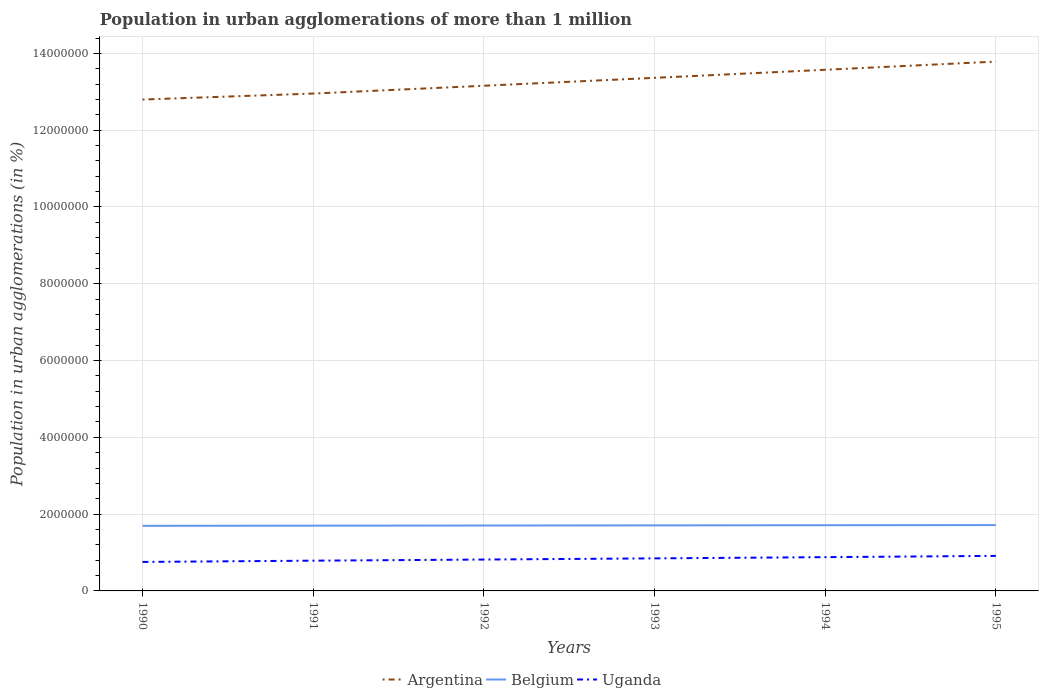Does the line corresponding to Argentina intersect with the line corresponding to Belgium?
Offer a very short reply. No. Is the number of lines equal to the number of legend labels?
Make the answer very short. Yes. Across all years, what is the maximum population in urban agglomerations in Argentina?
Provide a succinct answer. 1.28e+07. In which year was the population in urban agglomerations in Argentina maximum?
Provide a succinct answer. 1990. What is the total population in urban agglomerations in Belgium in the graph?
Offer a terse response. -1.17e+04. What is the difference between the highest and the second highest population in urban agglomerations in Uganda?
Provide a succinct answer. 1.58e+05. What is the difference between the highest and the lowest population in urban agglomerations in Belgium?
Make the answer very short. 3. Is the population in urban agglomerations in Belgium strictly greater than the population in urban agglomerations in Uganda over the years?
Make the answer very short. No. How many lines are there?
Give a very brief answer. 3. Where does the legend appear in the graph?
Your answer should be very brief. Bottom center. How are the legend labels stacked?
Offer a very short reply. Horizontal. What is the title of the graph?
Your answer should be compact. Population in urban agglomerations of more than 1 million. What is the label or title of the X-axis?
Give a very brief answer. Years. What is the label or title of the Y-axis?
Offer a very short reply. Population in urban agglomerations (in %). What is the Population in urban agglomerations (in %) in Argentina in 1990?
Offer a terse response. 1.28e+07. What is the Population in urban agglomerations (in %) in Belgium in 1990?
Your answer should be compact. 1.70e+06. What is the Population in urban agglomerations (in %) of Uganda in 1990?
Offer a terse response. 7.55e+05. What is the Population in urban agglomerations (in %) in Argentina in 1991?
Provide a short and direct response. 1.30e+07. What is the Population in urban agglomerations (in %) in Belgium in 1991?
Ensure brevity in your answer.  1.70e+06. What is the Population in urban agglomerations (in %) of Uganda in 1991?
Your answer should be compact. 7.88e+05. What is the Population in urban agglomerations (in %) in Argentina in 1992?
Offer a very short reply. 1.32e+07. What is the Population in urban agglomerations (in %) of Belgium in 1992?
Ensure brevity in your answer.  1.70e+06. What is the Population in urban agglomerations (in %) in Uganda in 1992?
Provide a short and direct response. 8.17e+05. What is the Population in urban agglomerations (in %) of Argentina in 1993?
Ensure brevity in your answer.  1.34e+07. What is the Population in urban agglomerations (in %) in Belgium in 1993?
Ensure brevity in your answer.  1.71e+06. What is the Population in urban agglomerations (in %) in Uganda in 1993?
Keep it short and to the point. 8.48e+05. What is the Population in urban agglomerations (in %) in Argentina in 1994?
Your answer should be compact. 1.36e+07. What is the Population in urban agglomerations (in %) in Belgium in 1994?
Ensure brevity in your answer.  1.71e+06. What is the Population in urban agglomerations (in %) in Uganda in 1994?
Make the answer very short. 8.80e+05. What is the Population in urban agglomerations (in %) in Argentina in 1995?
Your answer should be compact. 1.38e+07. What is the Population in urban agglomerations (in %) of Belgium in 1995?
Offer a very short reply. 1.71e+06. What is the Population in urban agglomerations (in %) of Uganda in 1995?
Offer a very short reply. 9.12e+05. Across all years, what is the maximum Population in urban agglomerations (in %) of Argentina?
Your answer should be very brief. 1.38e+07. Across all years, what is the maximum Population in urban agglomerations (in %) of Belgium?
Your answer should be compact. 1.71e+06. Across all years, what is the maximum Population in urban agglomerations (in %) of Uganda?
Keep it short and to the point. 9.12e+05. Across all years, what is the minimum Population in urban agglomerations (in %) of Argentina?
Give a very brief answer. 1.28e+07. Across all years, what is the minimum Population in urban agglomerations (in %) of Belgium?
Provide a succinct answer. 1.70e+06. Across all years, what is the minimum Population in urban agglomerations (in %) of Uganda?
Give a very brief answer. 7.55e+05. What is the total Population in urban agglomerations (in %) in Argentina in the graph?
Offer a very short reply. 7.96e+07. What is the total Population in urban agglomerations (in %) of Belgium in the graph?
Give a very brief answer. 1.02e+07. What is the total Population in urban agglomerations (in %) of Uganda in the graph?
Your answer should be compact. 5.00e+06. What is the difference between the Population in urban agglomerations (in %) of Argentina in 1990 and that in 1991?
Provide a short and direct response. -1.56e+05. What is the difference between the Population in urban agglomerations (in %) of Belgium in 1990 and that in 1991?
Offer a terse response. -3884. What is the difference between the Population in urban agglomerations (in %) in Uganda in 1990 and that in 1991?
Give a very brief answer. -3.28e+04. What is the difference between the Population in urban agglomerations (in %) in Argentina in 1990 and that in 1992?
Your response must be concise. -3.59e+05. What is the difference between the Population in urban agglomerations (in %) of Belgium in 1990 and that in 1992?
Offer a terse response. -7781. What is the difference between the Population in urban agglomerations (in %) of Uganda in 1990 and that in 1992?
Keep it short and to the point. -6.24e+04. What is the difference between the Population in urban agglomerations (in %) of Argentina in 1990 and that in 1993?
Provide a short and direct response. -5.65e+05. What is the difference between the Population in urban agglomerations (in %) in Belgium in 1990 and that in 1993?
Provide a short and direct response. -1.17e+04. What is the difference between the Population in urban agglomerations (in %) in Uganda in 1990 and that in 1993?
Offer a very short reply. -9.29e+04. What is the difference between the Population in urban agglomerations (in %) of Argentina in 1990 and that in 1994?
Your response must be concise. -7.75e+05. What is the difference between the Population in urban agglomerations (in %) of Belgium in 1990 and that in 1994?
Your answer should be compact. -1.56e+04. What is the difference between the Population in urban agglomerations (in %) of Uganda in 1990 and that in 1994?
Your answer should be compact. -1.25e+05. What is the difference between the Population in urban agglomerations (in %) in Argentina in 1990 and that in 1995?
Make the answer very short. -9.88e+05. What is the difference between the Population in urban agglomerations (in %) in Belgium in 1990 and that in 1995?
Ensure brevity in your answer.  -1.95e+04. What is the difference between the Population in urban agglomerations (in %) of Uganda in 1990 and that in 1995?
Give a very brief answer. -1.58e+05. What is the difference between the Population in urban agglomerations (in %) of Argentina in 1991 and that in 1992?
Your answer should be very brief. -2.03e+05. What is the difference between the Population in urban agglomerations (in %) of Belgium in 1991 and that in 1992?
Offer a terse response. -3897. What is the difference between the Population in urban agglomerations (in %) of Uganda in 1991 and that in 1992?
Your answer should be compact. -2.95e+04. What is the difference between the Population in urban agglomerations (in %) in Argentina in 1991 and that in 1993?
Your answer should be compact. -4.10e+05. What is the difference between the Population in urban agglomerations (in %) of Belgium in 1991 and that in 1993?
Keep it short and to the point. -7793. What is the difference between the Population in urban agglomerations (in %) of Uganda in 1991 and that in 1993?
Your response must be concise. -6.01e+04. What is the difference between the Population in urban agglomerations (in %) in Argentina in 1991 and that in 1994?
Provide a succinct answer. -6.19e+05. What is the difference between the Population in urban agglomerations (in %) in Belgium in 1991 and that in 1994?
Offer a very short reply. -1.17e+04. What is the difference between the Population in urban agglomerations (in %) of Uganda in 1991 and that in 1994?
Give a very brief answer. -9.19e+04. What is the difference between the Population in urban agglomerations (in %) of Argentina in 1991 and that in 1995?
Give a very brief answer. -8.33e+05. What is the difference between the Population in urban agglomerations (in %) in Belgium in 1991 and that in 1995?
Keep it short and to the point. -1.56e+04. What is the difference between the Population in urban agglomerations (in %) of Uganda in 1991 and that in 1995?
Your answer should be compact. -1.25e+05. What is the difference between the Population in urban agglomerations (in %) in Argentina in 1992 and that in 1993?
Keep it short and to the point. -2.06e+05. What is the difference between the Population in urban agglomerations (in %) of Belgium in 1992 and that in 1993?
Provide a succinct answer. -3896. What is the difference between the Population in urban agglomerations (in %) of Uganda in 1992 and that in 1993?
Ensure brevity in your answer.  -3.06e+04. What is the difference between the Population in urban agglomerations (in %) of Argentina in 1992 and that in 1994?
Ensure brevity in your answer.  -4.16e+05. What is the difference between the Population in urban agglomerations (in %) of Belgium in 1992 and that in 1994?
Your answer should be compact. -7806. What is the difference between the Population in urban agglomerations (in %) in Uganda in 1992 and that in 1994?
Your response must be concise. -6.23e+04. What is the difference between the Population in urban agglomerations (in %) in Argentina in 1992 and that in 1995?
Ensure brevity in your answer.  -6.29e+05. What is the difference between the Population in urban agglomerations (in %) of Belgium in 1992 and that in 1995?
Your response must be concise. -1.17e+04. What is the difference between the Population in urban agglomerations (in %) of Uganda in 1992 and that in 1995?
Provide a short and direct response. -9.53e+04. What is the difference between the Population in urban agglomerations (in %) of Argentina in 1993 and that in 1994?
Provide a short and direct response. -2.10e+05. What is the difference between the Population in urban agglomerations (in %) in Belgium in 1993 and that in 1994?
Keep it short and to the point. -3910. What is the difference between the Population in urban agglomerations (in %) of Uganda in 1993 and that in 1994?
Ensure brevity in your answer.  -3.18e+04. What is the difference between the Population in urban agglomerations (in %) in Argentina in 1993 and that in 1995?
Ensure brevity in your answer.  -4.23e+05. What is the difference between the Population in urban agglomerations (in %) in Belgium in 1993 and that in 1995?
Your answer should be compact. -7829. What is the difference between the Population in urban agglomerations (in %) of Uganda in 1993 and that in 1995?
Offer a terse response. -6.47e+04. What is the difference between the Population in urban agglomerations (in %) of Argentina in 1994 and that in 1995?
Offer a terse response. -2.13e+05. What is the difference between the Population in urban agglomerations (in %) in Belgium in 1994 and that in 1995?
Your answer should be compact. -3919. What is the difference between the Population in urban agglomerations (in %) in Uganda in 1994 and that in 1995?
Keep it short and to the point. -3.29e+04. What is the difference between the Population in urban agglomerations (in %) of Argentina in 1990 and the Population in urban agglomerations (in %) of Belgium in 1991?
Make the answer very short. 1.11e+07. What is the difference between the Population in urban agglomerations (in %) of Argentina in 1990 and the Population in urban agglomerations (in %) of Uganda in 1991?
Keep it short and to the point. 1.20e+07. What is the difference between the Population in urban agglomerations (in %) in Belgium in 1990 and the Population in urban agglomerations (in %) in Uganda in 1991?
Your answer should be very brief. 9.08e+05. What is the difference between the Population in urban agglomerations (in %) of Argentina in 1990 and the Population in urban agglomerations (in %) of Belgium in 1992?
Give a very brief answer. 1.11e+07. What is the difference between the Population in urban agglomerations (in %) in Argentina in 1990 and the Population in urban agglomerations (in %) in Uganda in 1992?
Provide a short and direct response. 1.20e+07. What is the difference between the Population in urban agglomerations (in %) in Belgium in 1990 and the Population in urban agglomerations (in %) in Uganda in 1992?
Offer a very short reply. 8.78e+05. What is the difference between the Population in urban agglomerations (in %) of Argentina in 1990 and the Population in urban agglomerations (in %) of Belgium in 1993?
Make the answer very short. 1.11e+07. What is the difference between the Population in urban agglomerations (in %) in Argentina in 1990 and the Population in urban agglomerations (in %) in Uganda in 1993?
Your answer should be very brief. 1.19e+07. What is the difference between the Population in urban agglomerations (in %) of Belgium in 1990 and the Population in urban agglomerations (in %) of Uganda in 1993?
Provide a succinct answer. 8.48e+05. What is the difference between the Population in urban agglomerations (in %) in Argentina in 1990 and the Population in urban agglomerations (in %) in Belgium in 1994?
Keep it short and to the point. 1.11e+07. What is the difference between the Population in urban agglomerations (in %) of Argentina in 1990 and the Population in urban agglomerations (in %) of Uganda in 1994?
Your answer should be very brief. 1.19e+07. What is the difference between the Population in urban agglomerations (in %) of Belgium in 1990 and the Population in urban agglomerations (in %) of Uganda in 1994?
Your answer should be very brief. 8.16e+05. What is the difference between the Population in urban agglomerations (in %) in Argentina in 1990 and the Population in urban agglomerations (in %) in Belgium in 1995?
Make the answer very short. 1.11e+07. What is the difference between the Population in urban agglomerations (in %) of Argentina in 1990 and the Population in urban agglomerations (in %) of Uganda in 1995?
Your answer should be compact. 1.19e+07. What is the difference between the Population in urban agglomerations (in %) in Belgium in 1990 and the Population in urban agglomerations (in %) in Uganda in 1995?
Give a very brief answer. 7.83e+05. What is the difference between the Population in urban agglomerations (in %) in Argentina in 1991 and the Population in urban agglomerations (in %) in Belgium in 1992?
Give a very brief answer. 1.12e+07. What is the difference between the Population in urban agglomerations (in %) of Argentina in 1991 and the Population in urban agglomerations (in %) of Uganda in 1992?
Keep it short and to the point. 1.21e+07. What is the difference between the Population in urban agglomerations (in %) of Belgium in 1991 and the Population in urban agglomerations (in %) of Uganda in 1992?
Your response must be concise. 8.82e+05. What is the difference between the Population in urban agglomerations (in %) of Argentina in 1991 and the Population in urban agglomerations (in %) of Belgium in 1993?
Give a very brief answer. 1.12e+07. What is the difference between the Population in urban agglomerations (in %) of Argentina in 1991 and the Population in urban agglomerations (in %) of Uganda in 1993?
Give a very brief answer. 1.21e+07. What is the difference between the Population in urban agglomerations (in %) in Belgium in 1991 and the Population in urban agglomerations (in %) in Uganda in 1993?
Your response must be concise. 8.52e+05. What is the difference between the Population in urban agglomerations (in %) in Argentina in 1991 and the Population in urban agglomerations (in %) in Belgium in 1994?
Ensure brevity in your answer.  1.12e+07. What is the difference between the Population in urban agglomerations (in %) in Argentina in 1991 and the Population in urban agglomerations (in %) in Uganda in 1994?
Keep it short and to the point. 1.21e+07. What is the difference between the Population in urban agglomerations (in %) of Belgium in 1991 and the Population in urban agglomerations (in %) of Uganda in 1994?
Ensure brevity in your answer.  8.20e+05. What is the difference between the Population in urban agglomerations (in %) of Argentina in 1991 and the Population in urban agglomerations (in %) of Belgium in 1995?
Provide a short and direct response. 1.12e+07. What is the difference between the Population in urban agglomerations (in %) of Argentina in 1991 and the Population in urban agglomerations (in %) of Uganda in 1995?
Your answer should be very brief. 1.20e+07. What is the difference between the Population in urban agglomerations (in %) in Belgium in 1991 and the Population in urban agglomerations (in %) in Uganda in 1995?
Keep it short and to the point. 7.87e+05. What is the difference between the Population in urban agglomerations (in %) in Argentina in 1992 and the Population in urban agglomerations (in %) in Belgium in 1993?
Your response must be concise. 1.14e+07. What is the difference between the Population in urban agglomerations (in %) of Argentina in 1992 and the Population in urban agglomerations (in %) of Uganda in 1993?
Offer a terse response. 1.23e+07. What is the difference between the Population in urban agglomerations (in %) of Belgium in 1992 and the Population in urban agglomerations (in %) of Uganda in 1993?
Provide a succinct answer. 8.55e+05. What is the difference between the Population in urban agglomerations (in %) of Argentina in 1992 and the Population in urban agglomerations (in %) of Belgium in 1994?
Give a very brief answer. 1.14e+07. What is the difference between the Population in urban agglomerations (in %) of Argentina in 1992 and the Population in urban agglomerations (in %) of Uganda in 1994?
Your answer should be compact. 1.23e+07. What is the difference between the Population in urban agglomerations (in %) of Belgium in 1992 and the Population in urban agglomerations (in %) of Uganda in 1994?
Give a very brief answer. 8.24e+05. What is the difference between the Population in urban agglomerations (in %) of Argentina in 1992 and the Population in urban agglomerations (in %) of Belgium in 1995?
Your answer should be compact. 1.14e+07. What is the difference between the Population in urban agglomerations (in %) in Argentina in 1992 and the Population in urban agglomerations (in %) in Uganda in 1995?
Offer a terse response. 1.22e+07. What is the difference between the Population in urban agglomerations (in %) of Belgium in 1992 and the Population in urban agglomerations (in %) of Uganda in 1995?
Offer a terse response. 7.91e+05. What is the difference between the Population in urban agglomerations (in %) in Argentina in 1993 and the Population in urban agglomerations (in %) in Belgium in 1994?
Ensure brevity in your answer.  1.17e+07. What is the difference between the Population in urban agglomerations (in %) of Argentina in 1993 and the Population in urban agglomerations (in %) of Uganda in 1994?
Provide a succinct answer. 1.25e+07. What is the difference between the Population in urban agglomerations (in %) in Belgium in 1993 and the Population in urban agglomerations (in %) in Uganda in 1994?
Ensure brevity in your answer.  8.28e+05. What is the difference between the Population in urban agglomerations (in %) in Argentina in 1993 and the Population in urban agglomerations (in %) in Belgium in 1995?
Provide a short and direct response. 1.16e+07. What is the difference between the Population in urban agglomerations (in %) in Argentina in 1993 and the Population in urban agglomerations (in %) in Uganda in 1995?
Keep it short and to the point. 1.25e+07. What is the difference between the Population in urban agglomerations (in %) in Belgium in 1993 and the Population in urban agglomerations (in %) in Uganda in 1995?
Offer a terse response. 7.95e+05. What is the difference between the Population in urban agglomerations (in %) of Argentina in 1994 and the Population in urban agglomerations (in %) of Belgium in 1995?
Offer a terse response. 1.19e+07. What is the difference between the Population in urban agglomerations (in %) of Argentina in 1994 and the Population in urban agglomerations (in %) of Uganda in 1995?
Your answer should be compact. 1.27e+07. What is the difference between the Population in urban agglomerations (in %) in Belgium in 1994 and the Population in urban agglomerations (in %) in Uganda in 1995?
Ensure brevity in your answer.  7.99e+05. What is the average Population in urban agglomerations (in %) of Argentina per year?
Ensure brevity in your answer.  1.33e+07. What is the average Population in urban agglomerations (in %) in Belgium per year?
Provide a succinct answer. 1.71e+06. What is the average Population in urban agglomerations (in %) in Uganda per year?
Keep it short and to the point. 8.33e+05. In the year 1990, what is the difference between the Population in urban agglomerations (in %) in Argentina and Population in urban agglomerations (in %) in Belgium?
Give a very brief answer. 1.11e+07. In the year 1990, what is the difference between the Population in urban agglomerations (in %) of Argentina and Population in urban agglomerations (in %) of Uganda?
Your response must be concise. 1.20e+07. In the year 1990, what is the difference between the Population in urban agglomerations (in %) in Belgium and Population in urban agglomerations (in %) in Uganda?
Give a very brief answer. 9.41e+05. In the year 1991, what is the difference between the Population in urban agglomerations (in %) in Argentina and Population in urban agglomerations (in %) in Belgium?
Provide a succinct answer. 1.13e+07. In the year 1991, what is the difference between the Population in urban agglomerations (in %) in Argentina and Population in urban agglomerations (in %) in Uganda?
Offer a very short reply. 1.22e+07. In the year 1991, what is the difference between the Population in urban agglomerations (in %) of Belgium and Population in urban agglomerations (in %) of Uganda?
Ensure brevity in your answer.  9.12e+05. In the year 1992, what is the difference between the Population in urban agglomerations (in %) of Argentina and Population in urban agglomerations (in %) of Belgium?
Offer a very short reply. 1.15e+07. In the year 1992, what is the difference between the Population in urban agglomerations (in %) of Argentina and Population in urban agglomerations (in %) of Uganda?
Keep it short and to the point. 1.23e+07. In the year 1992, what is the difference between the Population in urban agglomerations (in %) of Belgium and Population in urban agglomerations (in %) of Uganda?
Your answer should be compact. 8.86e+05. In the year 1993, what is the difference between the Population in urban agglomerations (in %) of Argentina and Population in urban agglomerations (in %) of Belgium?
Provide a succinct answer. 1.17e+07. In the year 1993, what is the difference between the Population in urban agglomerations (in %) in Argentina and Population in urban agglomerations (in %) in Uganda?
Offer a very short reply. 1.25e+07. In the year 1993, what is the difference between the Population in urban agglomerations (in %) of Belgium and Population in urban agglomerations (in %) of Uganda?
Your answer should be compact. 8.59e+05. In the year 1994, what is the difference between the Population in urban agglomerations (in %) in Argentina and Population in urban agglomerations (in %) in Belgium?
Provide a short and direct response. 1.19e+07. In the year 1994, what is the difference between the Population in urban agglomerations (in %) of Argentina and Population in urban agglomerations (in %) of Uganda?
Give a very brief answer. 1.27e+07. In the year 1994, what is the difference between the Population in urban agglomerations (in %) of Belgium and Population in urban agglomerations (in %) of Uganda?
Make the answer very short. 8.32e+05. In the year 1995, what is the difference between the Population in urban agglomerations (in %) of Argentina and Population in urban agglomerations (in %) of Belgium?
Ensure brevity in your answer.  1.21e+07. In the year 1995, what is the difference between the Population in urban agglomerations (in %) of Argentina and Population in urban agglomerations (in %) of Uganda?
Give a very brief answer. 1.29e+07. In the year 1995, what is the difference between the Population in urban agglomerations (in %) in Belgium and Population in urban agglomerations (in %) in Uganda?
Offer a very short reply. 8.02e+05. What is the ratio of the Population in urban agglomerations (in %) of Argentina in 1990 to that in 1991?
Ensure brevity in your answer.  0.99. What is the ratio of the Population in urban agglomerations (in %) in Belgium in 1990 to that in 1991?
Offer a very short reply. 1. What is the ratio of the Population in urban agglomerations (in %) of Uganda in 1990 to that in 1991?
Provide a succinct answer. 0.96. What is the ratio of the Population in urban agglomerations (in %) of Argentina in 1990 to that in 1992?
Your response must be concise. 0.97. What is the ratio of the Population in urban agglomerations (in %) in Belgium in 1990 to that in 1992?
Provide a short and direct response. 1. What is the ratio of the Population in urban agglomerations (in %) of Uganda in 1990 to that in 1992?
Offer a very short reply. 0.92. What is the ratio of the Population in urban agglomerations (in %) of Argentina in 1990 to that in 1993?
Make the answer very short. 0.96. What is the ratio of the Population in urban agglomerations (in %) of Uganda in 1990 to that in 1993?
Your answer should be compact. 0.89. What is the ratio of the Population in urban agglomerations (in %) in Argentina in 1990 to that in 1994?
Make the answer very short. 0.94. What is the ratio of the Population in urban agglomerations (in %) of Belgium in 1990 to that in 1994?
Ensure brevity in your answer.  0.99. What is the ratio of the Population in urban agglomerations (in %) in Uganda in 1990 to that in 1994?
Provide a short and direct response. 0.86. What is the ratio of the Population in urban agglomerations (in %) of Argentina in 1990 to that in 1995?
Provide a succinct answer. 0.93. What is the ratio of the Population in urban agglomerations (in %) in Uganda in 1990 to that in 1995?
Offer a terse response. 0.83. What is the ratio of the Population in urban agglomerations (in %) of Argentina in 1991 to that in 1992?
Provide a succinct answer. 0.98. What is the ratio of the Population in urban agglomerations (in %) in Uganda in 1991 to that in 1992?
Your response must be concise. 0.96. What is the ratio of the Population in urban agglomerations (in %) of Argentina in 1991 to that in 1993?
Provide a succinct answer. 0.97. What is the ratio of the Population in urban agglomerations (in %) of Uganda in 1991 to that in 1993?
Offer a very short reply. 0.93. What is the ratio of the Population in urban agglomerations (in %) in Argentina in 1991 to that in 1994?
Offer a terse response. 0.95. What is the ratio of the Population in urban agglomerations (in %) in Uganda in 1991 to that in 1994?
Your response must be concise. 0.9. What is the ratio of the Population in urban agglomerations (in %) in Argentina in 1991 to that in 1995?
Your response must be concise. 0.94. What is the ratio of the Population in urban agglomerations (in %) in Belgium in 1991 to that in 1995?
Offer a terse response. 0.99. What is the ratio of the Population in urban agglomerations (in %) in Uganda in 1991 to that in 1995?
Provide a short and direct response. 0.86. What is the ratio of the Population in urban agglomerations (in %) of Argentina in 1992 to that in 1993?
Your response must be concise. 0.98. What is the ratio of the Population in urban agglomerations (in %) of Uganda in 1992 to that in 1993?
Your answer should be compact. 0.96. What is the ratio of the Population in urban agglomerations (in %) of Argentina in 1992 to that in 1994?
Provide a succinct answer. 0.97. What is the ratio of the Population in urban agglomerations (in %) of Belgium in 1992 to that in 1994?
Provide a succinct answer. 1. What is the ratio of the Population in urban agglomerations (in %) of Uganda in 1992 to that in 1994?
Your answer should be compact. 0.93. What is the ratio of the Population in urban agglomerations (in %) of Argentina in 1992 to that in 1995?
Ensure brevity in your answer.  0.95. What is the ratio of the Population in urban agglomerations (in %) of Uganda in 1992 to that in 1995?
Provide a short and direct response. 0.9. What is the ratio of the Population in urban agglomerations (in %) in Argentina in 1993 to that in 1994?
Give a very brief answer. 0.98. What is the ratio of the Population in urban agglomerations (in %) of Belgium in 1993 to that in 1994?
Your answer should be compact. 1. What is the ratio of the Population in urban agglomerations (in %) of Uganda in 1993 to that in 1994?
Provide a succinct answer. 0.96. What is the ratio of the Population in urban agglomerations (in %) in Argentina in 1993 to that in 1995?
Keep it short and to the point. 0.97. What is the ratio of the Population in urban agglomerations (in %) in Uganda in 1993 to that in 1995?
Your response must be concise. 0.93. What is the ratio of the Population in urban agglomerations (in %) in Argentina in 1994 to that in 1995?
Provide a short and direct response. 0.98. What is the ratio of the Population in urban agglomerations (in %) of Belgium in 1994 to that in 1995?
Give a very brief answer. 1. What is the ratio of the Population in urban agglomerations (in %) in Uganda in 1994 to that in 1995?
Make the answer very short. 0.96. What is the difference between the highest and the second highest Population in urban agglomerations (in %) of Argentina?
Offer a very short reply. 2.13e+05. What is the difference between the highest and the second highest Population in urban agglomerations (in %) in Belgium?
Offer a terse response. 3919. What is the difference between the highest and the second highest Population in urban agglomerations (in %) in Uganda?
Make the answer very short. 3.29e+04. What is the difference between the highest and the lowest Population in urban agglomerations (in %) in Argentina?
Your answer should be very brief. 9.88e+05. What is the difference between the highest and the lowest Population in urban agglomerations (in %) in Belgium?
Provide a short and direct response. 1.95e+04. What is the difference between the highest and the lowest Population in urban agglomerations (in %) of Uganda?
Offer a terse response. 1.58e+05. 